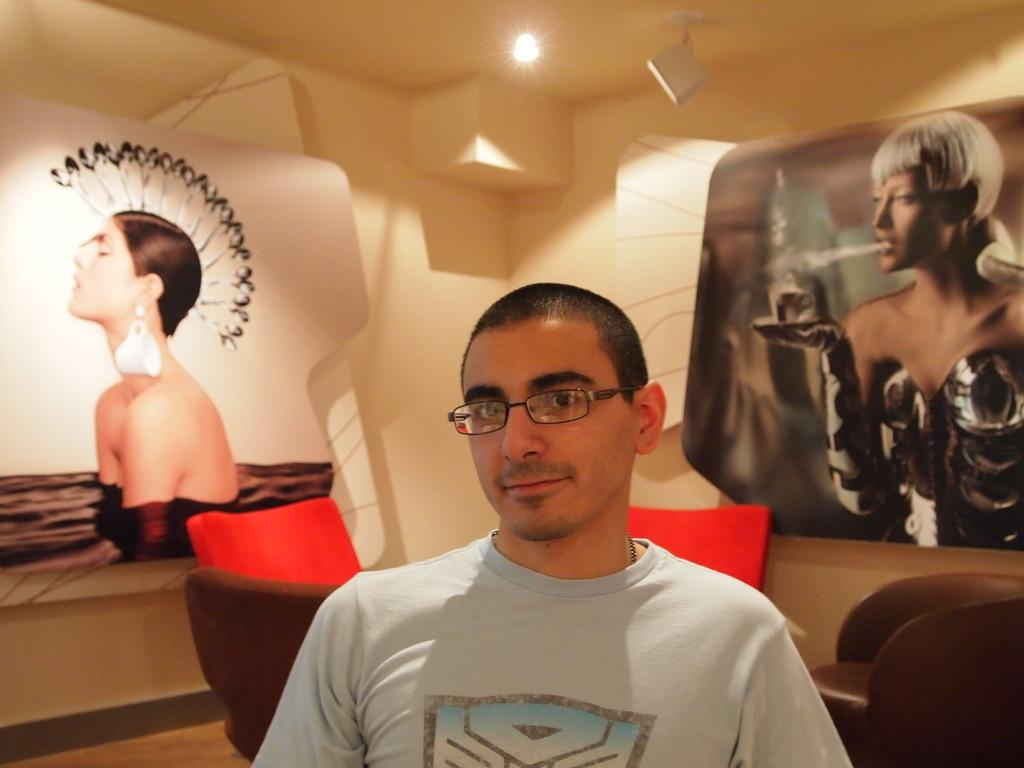What is the person in the image wearing? The person in the image is wearing a t-shirt and specs. What can be seen in the background of the image? There are chairs in the background of the image. What are the two people doing in the image? The two people are on boards in the image. What is the source of light visible in the image? There is a light visible at the top of the image. What type of zephyr can be seen blowing through the person's hair in the image? There is no zephyr present in the image, and the person's hair is not being blown by any wind. 